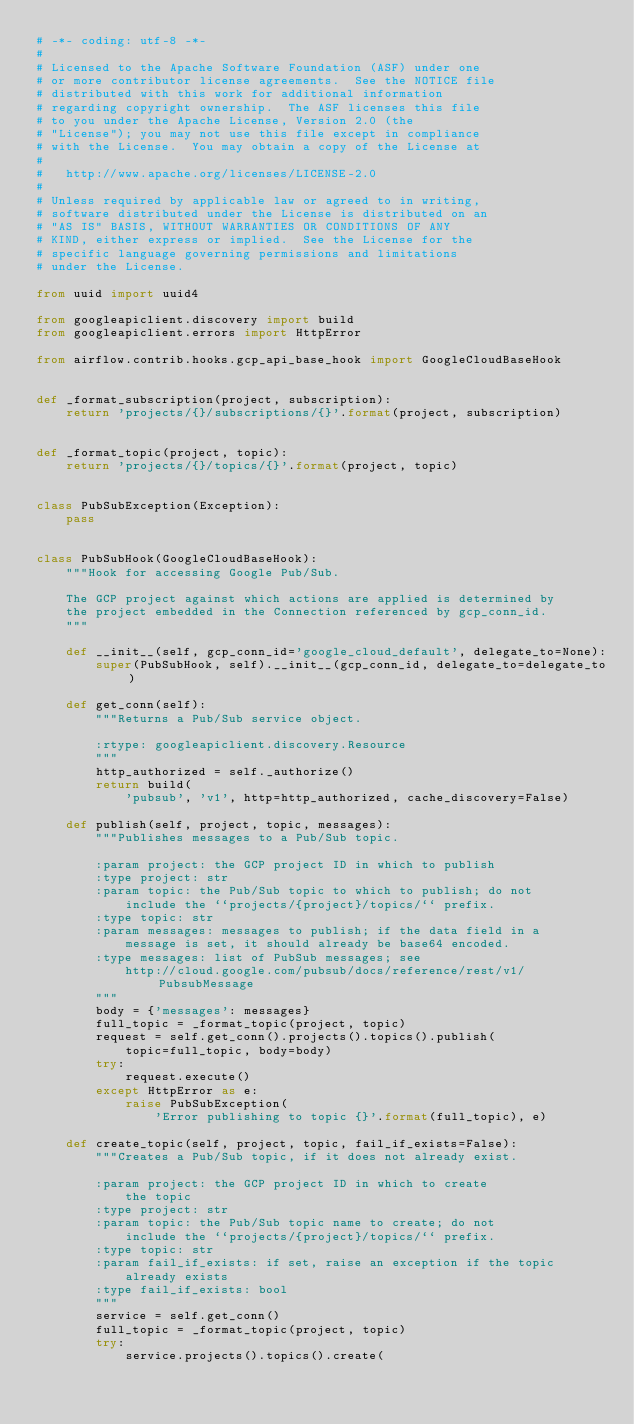Convert code to text. <code><loc_0><loc_0><loc_500><loc_500><_Python_># -*- coding: utf-8 -*-
#
# Licensed to the Apache Software Foundation (ASF) under one
# or more contributor license agreements.  See the NOTICE file
# distributed with this work for additional information
# regarding copyright ownership.  The ASF licenses this file
# to you under the Apache License, Version 2.0 (the
# "License"); you may not use this file except in compliance
# with the License.  You may obtain a copy of the License at
#
#   http://www.apache.org/licenses/LICENSE-2.0
#
# Unless required by applicable law or agreed to in writing,
# software distributed under the License is distributed on an
# "AS IS" BASIS, WITHOUT WARRANTIES OR CONDITIONS OF ANY
# KIND, either express or implied.  See the License for the
# specific language governing permissions and limitations
# under the License.

from uuid import uuid4

from googleapiclient.discovery import build
from googleapiclient.errors import HttpError

from airflow.contrib.hooks.gcp_api_base_hook import GoogleCloudBaseHook


def _format_subscription(project, subscription):
    return 'projects/{}/subscriptions/{}'.format(project, subscription)


def _format_topic(project, topic):
    return 'projects/{}/topics/{}'.format(project, topic)


class PubSubException(Exception):
    pass


class PubSubHook(GoogleCloudBaseHook):
    """Hook for accessing Google Pub/Sub.

    The GCP project against which actions are applied is determined by
    the project embedded in the Connection referenced by gcp_conn_id.
    """

    def __init__(self, gcp_conn_id='google_cloud_default', delegate_to=None):
        super(PubSubHook, self).__init__(gcp_conn_id, delegate_to=delegate_to)

    def get_conn(self):
        """Returns a Pub/Sub service object.

        :rtype: googleapiclient.discovery.Resource
        """
        http_authorized = self._authorize()
        return build(
            'pubsub', 'v1', http=http_authorized, cache_discovery=False)

    def publish(self, project, topic, messages):
        """Publishes messages to a Pub/Sub topic.

        :param project: the GCP project ID in which to publish
        :type project: str
        :param topic: the Pub/Sub topic to which to publish; do not
            include the ``projects/{project}/topics/`` prefix.
        :type topic: str
        :param messages: messages to publish; if the data field in a
            message is set, it should already be base64 encoded.
        :type messages: list of PubSub messages; see
            http://cloud.google.com/pubsub/docs/reference/rest/v1/PubsubMessage
        """
        body = {'messages': messages}
        full_topic = _format_topic(project, topic)
        request = self.get_conn().projects().topics().publish(
            topic=full_topic, body=body)
        try:
            request.execute()
        except HttpError as e:
            raise PubSubException(
                'Error publishing to topic {}'.format(full_topic), e)

    def create_topic(self, project, topic, fail_if_exists=False):
        """Creates a Pub/Sub topic, if it does not already exist.

        :param project: the GCP project ID in which to create
            the topic
        :type project: str
        :param topic: the Pub/Sub topic name to create; do not
            include the ``projects/{project}/topics/`` prefix.
        :type topic: str
        :param fail_if_exists: if set, raise an exception if the topic
            already exists
        :type fail_if_exists: bool
        """
        service = self.get_conn()
        full_topic = _format_topic(project, topic)
        try:
            service.projects().topics().create(</code> 